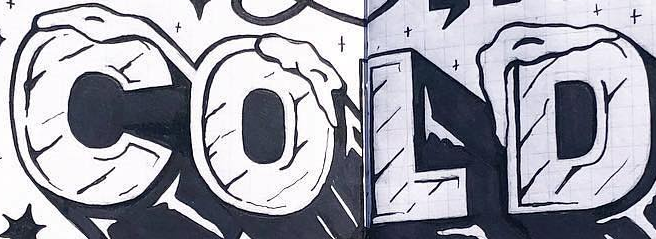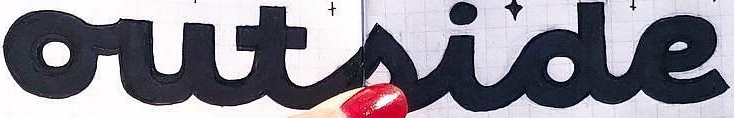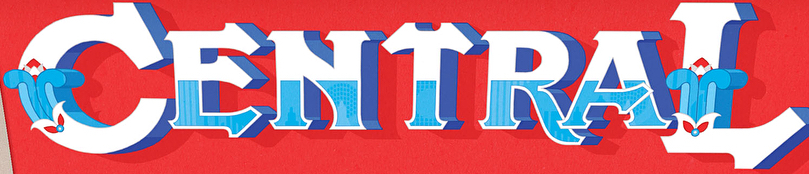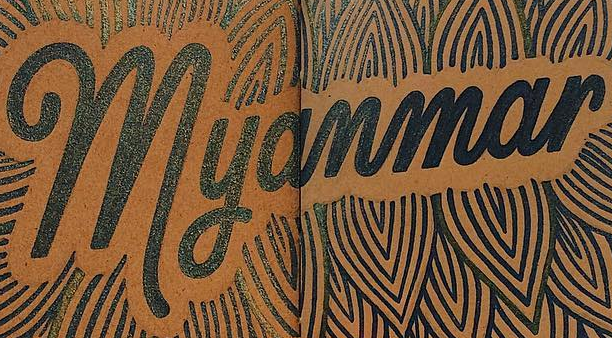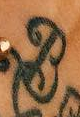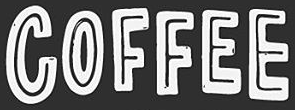What text is displayed in these images sequentially, separated by a semicolon? COLD; outside; CENTRAL; Myanmar; B; COFFEE 